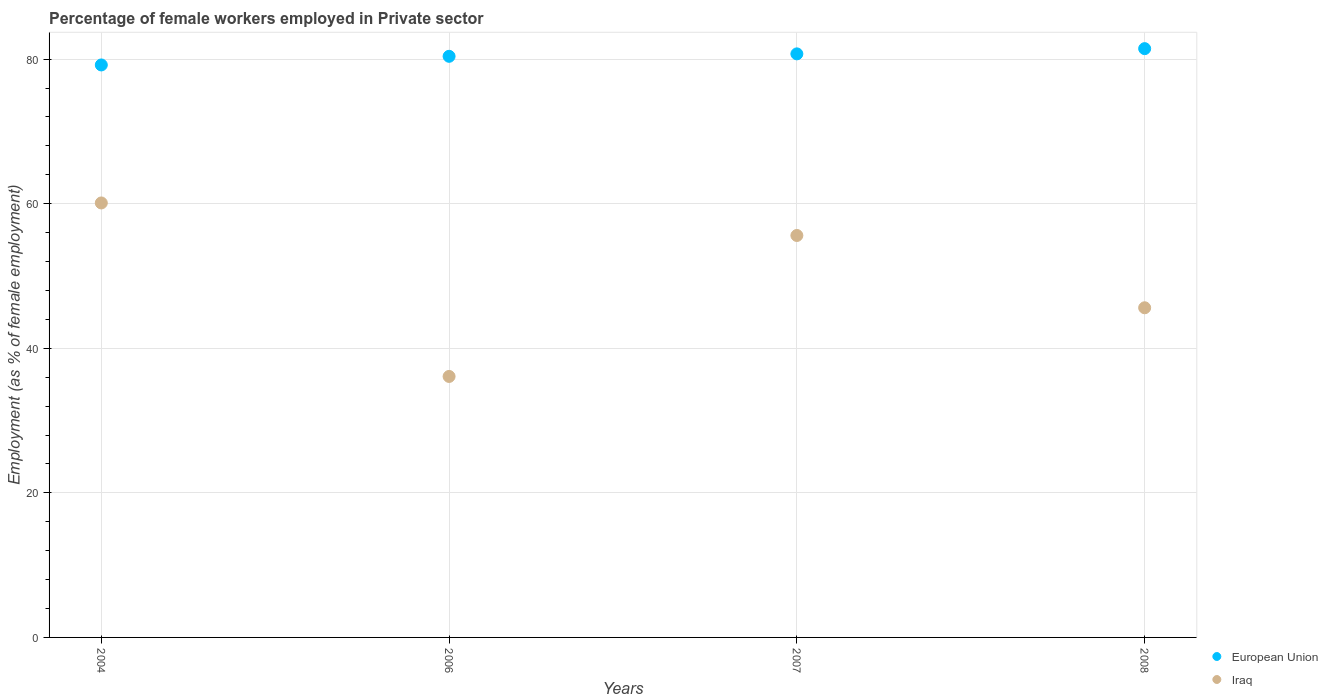What is the percentage of females employed in Private sector in Iraq in 2004?
Make the answer very short. 60.1. Across all years, what is the maximum percentage of females employed in Private sector in European Union?
Ensure brevity in your answer.  81.44. Across all years, what is the minimum percentage of females employed in Private sector in Iraq?
Your answer should be very brief. 36.1. In which year was the percentage of females employed in Private sector in Iraq minimum?
Make the answer very short. 2006. What is the total percentage of females employed in Private sector in European Union in the graph?
Your answer should be compact. 321.74. What is the difference between the percentage of females employed in Private sector in Iraq in 2006 and that in 2007?
Provide a succinct answer. -19.5. What is the difference between the percentage of females employed in Private sector in Iraq in 2006 and the percentage of females employed in Private sector in European Union in 2004?
Keep it short and to the point. -43.09. What is the average percentage of females employed in Private sector in European Union per year?
Offer a terse response. 80.43. In the year 2004, what is the difference between the percentage of females employed in Private sector in European Union and percentage of females employed in Private sector in Iraq?
Keep it short and to the point. 19.09. What is the ratio of the percentage of females employed in Private sector in Iraq in 2004 to that in 2006?
Provide a short and direct response. 1.66. Is the percentage of females employed in Private sector in Iraq in 2006 less than that in 2008?
Your answer should be very brief. Yes. Is the difference between the percentage of females employed in Private sector in European Union in 2006 and 2007 greater than the difference between the percentage of females employed in Private sector in Iraq in 2006 and 2007?
Ensure brevity in your answer.  Yes. What is the difference between the highest and the second highest percentage of females employed in Private sector in European Union?
Provide a succinct answer. 0.72. What is the difference between the highest and the lowest percentage of females employed in Private sector in European Union?
Provide a short and direct response. 2.26. Does the percentage of females employed in Private sector in Iraq monotonically increase over the years?
Your answer should be compact. No. Is the percentage of females employed in Private sector in Iraq strictly greater than the percentage of females employed in Private sector in European Union over the years?
Your response must be concise. No. Is the percentage of females employed in Private sector in Iraq strictly less than the percentage of females employed in Private sector in European Union over the years?
Make the answer very short. Yes. How many dotlines are there?
Provide a short and direct response. 2. How many years are there in the graph?
Give a very brief answer. 4. Are the values on the major ticks of Y-axis written in scientific E-notation?
Provide a short and direct response. No. Does the graph contain any zero values?
Make the answer very short. No. What is the title of the graph?
Give a very brief answer. Percentage of female workers employed in Private sector. What is the label or title of the Y-axis?
Provide a short and direct response. Employment (as % of female employment). What is the Employment (as % of female employment) in European Union in 2004?
Keep it short and to the point. 79.19. What is the Employment (as % of female employment) in Iraq in 2004?
Your answer should be very brief. 60.1. What is the Employment (as % of female employment) of European Union in 2006?
Offer a very short reply. 80.38. What is the Employment (as % of female employment) in Iraq in 2006?
Offer a terse response. 36.1. What is the Employment (as % of female employment) in European Union in 2007?
Provide a short and direct response. 80.72. What is the Employment (as % of female employment) of Iraq in 2007?
Offer a terse response. 55.6. What is the Employment (as % of female employment) of European Union in 2008?
Keep it short and to the point. 81.44. What is the Employment (as % of female employment) of Iraq in 2008?
Give a very brief answer. 45.6. Across all years, what is the maximum Employment (as % of female employment) in European Union?
Provide a short and direct response. 81.44. Across all years, what is the maximum Employment (as % of female employment) of Iraq?
Your answer should be very brief. 60.1. Across all years, what is the minimum Employment (as % of female employment) in European Union?
Make the answer very short. 79.19. Across all years, what is the minimum Employment (as % of female employment) of Iraq?
Make the answer very short. 36.1. What is the total Employment (as % of female employment) in European Union in the graph?
Make the answer very short. 321.74. What is the total Employment (as % of female employment) in Iraq in the graph?
Give a very brief answer. 197.4. What is the difference between the Employment (as % of female employment) in European Union in 2004 and that in 2006?
Offer a terse response. -1.19. What is the difference between the Employment (as % of female employment) of Iraq in 2004 and that in 2006?
Your answer should be compact. 24. What is the difference between the Employment (as % of female employment) in European Union in 2004 and that in 2007?
Offer a terse response. -1.53. What is the difference between the Employment (as % of female employment) of Iraq in 2004 and that in 2007?
Keep it short and to the point. 4.5. What is the difference between the Employment (as % of female employment) of European Union in 2004 and that in 2008?
Your answer should be very brief. -2.26. What is the difference between the Employment (as % of female employment) of Iraq in 2004 and that in 2008?
Your answer should be very brief. 14.5. What is the difference between the Employment (as % of female employment) in European Union in 2006 and that in 2007?
Your answer should be compact. -0.34. What is the difference between the Employment (as % of female employment) of Iraq in 2006 and that in 2007?
Make the answer very short. -19.5. What is the difference between the Employment (as % of female employment) in European Union in 2006 and that in 2008?
Provide a succinct answer. -1.06. What is the difference between the Employment (as % of female employment) in Iraq in 2006 and that in 2008?
Provide a succinct answer. -9.5. What is the difference between the Employment (as % of female employment) in European Union in 2007 and that in 2008?
Make the answer very short. -0.72. What is the difference between the Employment (as % of female employment) of European Union in 2004 and the Employment (as % of female employment) of Iraq in 2006?
Offer a terse response. 43.09. What is the difference between the Employment (as % of female employment) of European Union in 2004 and the Employment (as % of female employment) of Iraq in 2007?
Keep it short and to the point. 23.59. What is the difference between the Employment (as % of female employment) of European Union in 2004 and the Employment (as % of female employment) of Iraq in 2008?
Keep it short and to the point. 33.59. What is the difference between the Employment (as % of female employment) of European Union in 2006 and the Employment (as % of female employment) of Iraq in 2007?
Provide a short and direct response. 24.78. What is the difference between the Employment (as % of female employment) in European Union in 2006 and the Employment (as % of female employment) in Iraq in 2008?
Your answer should be very brief. 34.78. What is the difference between the Employment (as % of female employment) of European Union in 2007 and the Employment (as % of female employment) of Iraq in 2008?
Your answer should be compact. 35.12. What is the average Employment (as % of female employment) of European Union per year?
Provide a short and direct response. 80.43. What is the average Employment (as % of female employment) in Iraq per year?
Make the answer very short. 49.35. In the year 2004, what is the difference between the Employment (as % of female employment) in European Union and Employment (as % of female employment) in Iraq?
Ensure brevity in your answer.  19.09. In the year 2006, what is the difference between the Employment (as % of female employment) in European Union and Employment (as % of female employment) in Iraq?
Provide a succinct answer. 44.28. In the year 2007, what is the difference between the Employment (as % of female employment) in European Union and Employment (as % of female employment) in Iraq?
Your answer should be very brief. 25.12. In the year 2008, what is the difference between the Employment (as % of female employment) of European Union and Employment (as % of female employment) of Iraq?
Ensure brevity in your answer.  35.84. What is the ratio of the Employment (as % of female employment) of European Union in 2004 to that in 2006?
Provide a succinct answer. 0.99. What is the ratio of the Employment (as % of female employment) of Iraq in 2004 to that in 2006?
Provide a succinct answer. 1.66. What is the ratio of the Employment (as % of female employment) of European Union in 2004 to that in 2007?
Your answer should be very brief. 0.98. What is the ratio of the Employment (as % of female employment) in Iraq in 2004 to that in 2007?
Your response must be concise. 1.08. What is the ratio of the Employment (as % of female employment) of European Union in 2004 to that in 2008?
Offer a terse response. 0.97. What is the ratio of the Employment (as % of female employment) in Iraq in 2004 to that in 2008?
Your response must be concise. 1.32. What is the ratio of the Employment (as % of female employment) in European Union in 2006 to that in 2007?
Provide a succinct answer. 1. What is the ratio of the Employment (as % of female employment) of Iraq in 2006 to that in 2007?
Make the answer very short. 0.65. What is the ratio of the Employment (as % of female employment) in Iraq in 2006 to that in 2008?
Provide a succinct answer. 0.79. What is the ratio of the Employment (as % of female employment) of Iraq in 2007 to that in 2008?
Keep it short and to the point. 1.22. What is the difference between the highest and the second highest Employment (as % of female employment) of European Union?
Your answer should be compact. 0.72. What is the difference between the highest and the second highest Employment (as % of female employment) in Iraq?
Keep it short and to the point. 4.5. What is the difference between the highest and the lowest Employment (as % of female employment) of European Union?
Provide a succinct answer. 2.26. What is the difference between the highest and the lowest Employment (as % of female employment) in Iraq?
Provide a succinct answer. 24. 